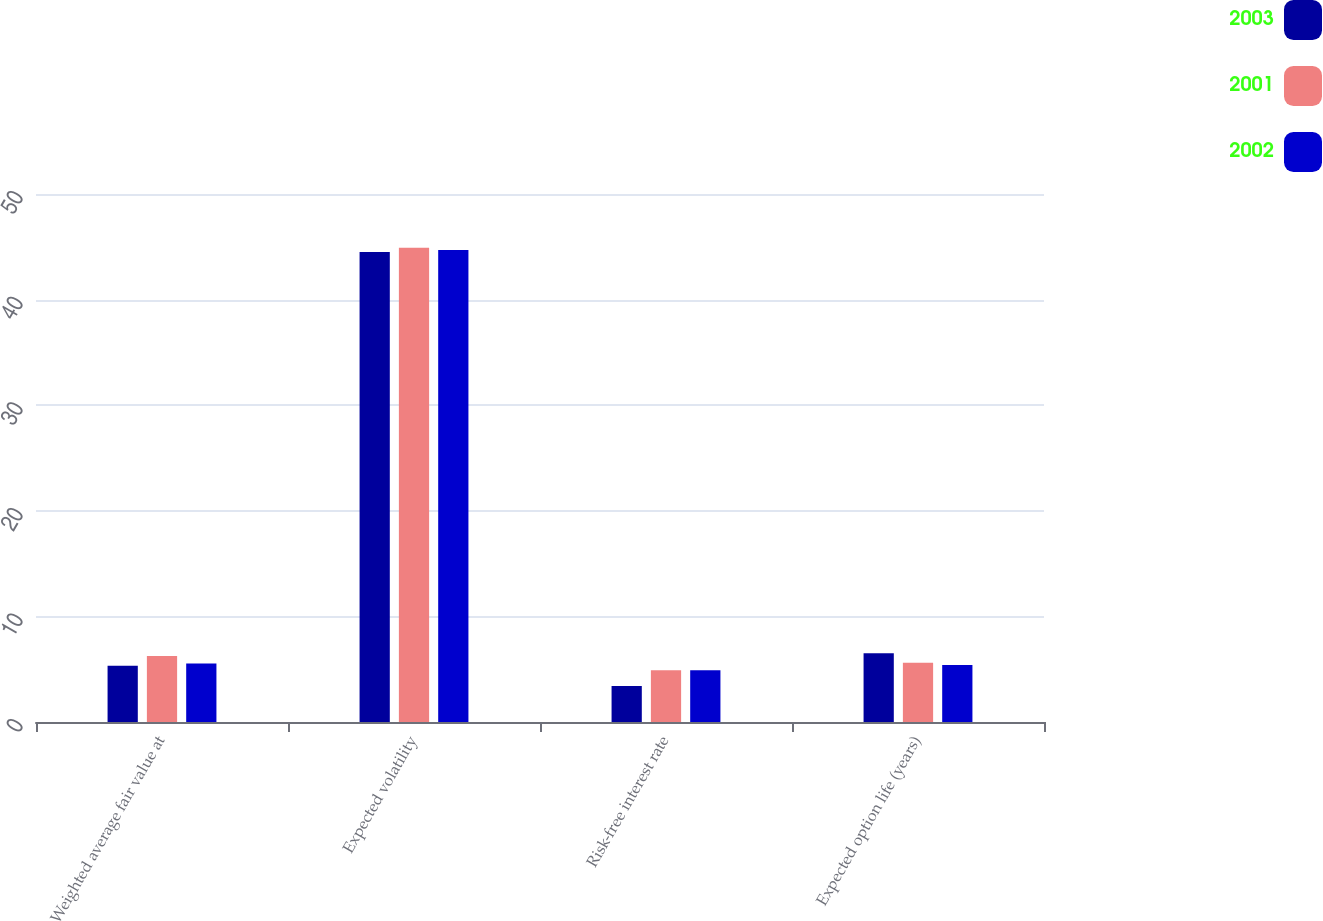<chart> <loc_0><loc_0><loc_500><loc_500><stacked_bar_chart><ecel><fcel>Weighted average fair value at<fcel>Expected volatility<fcel>Risk-free interest rate<fcel>Expected option life (years)<nl><fcel>2003<fcel>5.33<fcel>44.5<fcel>3.4<fcel>6.5<nl><fcel>2001<fcel>6.26<fcel>44.9<fcel>4.9<fcel>5.6<nl><fcel>2002<fcel>5.53<fcel>44.7<fcel>4.9<fcel>5.4<nl></chart> 